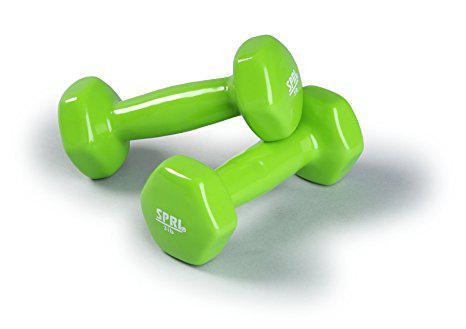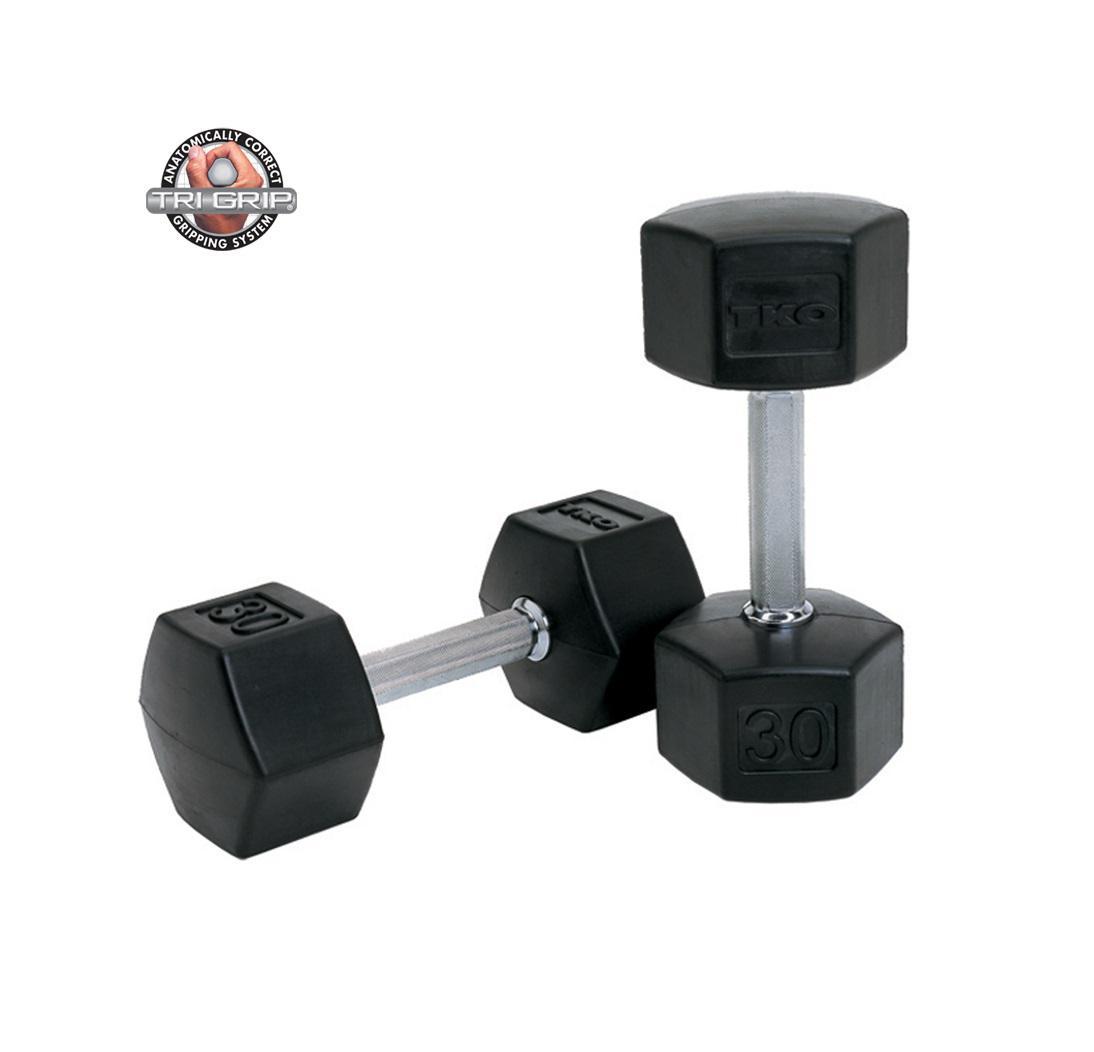The first image is the image on the left, the second image is the image on the right. Assess this claim about the two images: "All of the weights are green in both images.". Correct or not? Answer yes or no. No. The first image is the image on the left, the second image is the image on the right. Evaluate the accuracy of this statement regarding the images: "Images contain green dumbbells and contain the same number of dumbbells.". Is it true? Answer yes or no. No. 